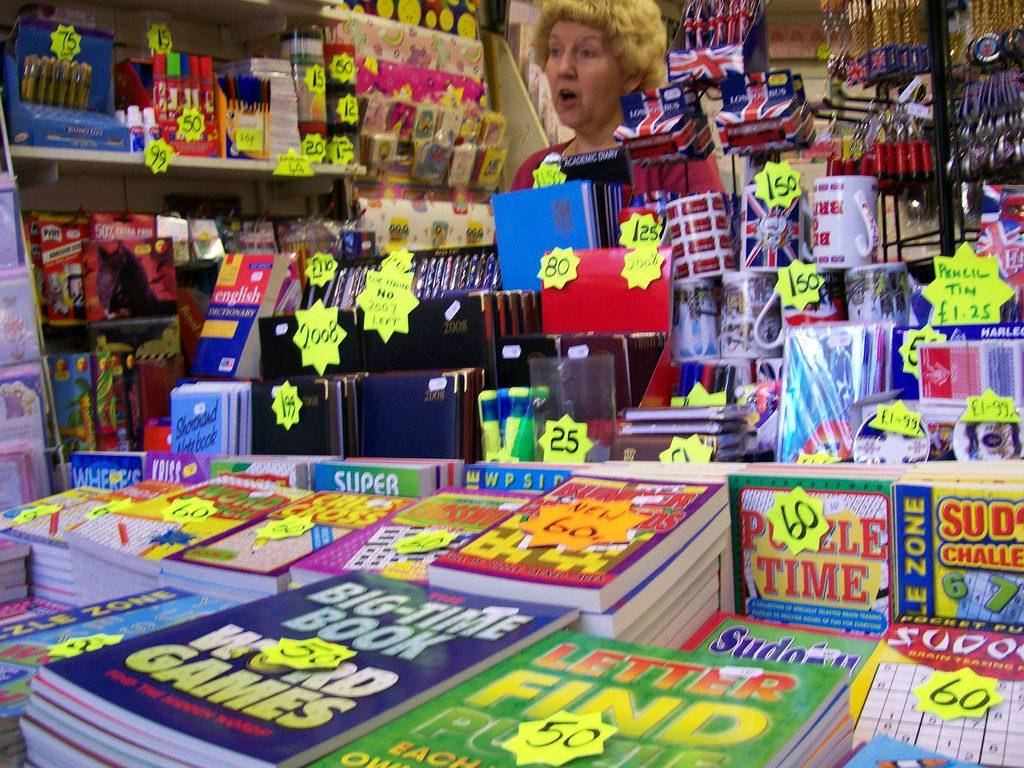<image>
Share a concise interpretation of the image provided. stacks of word game books and others on a table in a store 